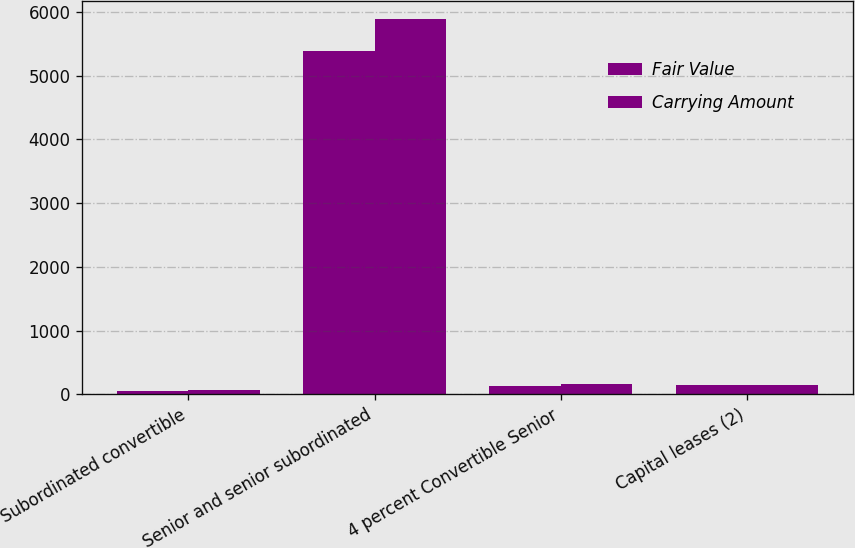<chart> <loc_0><loc_0><loc_500><loc_500><stacked_bar_chart><ecel><fcel>Subordinated convertible<fcel>Senior and senior subordinated<fcel>4 percent Convertible Senior<fcel>Capital leases (2)<nl><fcel>Fair Value<fcel>55<fcel>5387<fcel>137<fcel>148<nl><fcel>Carrying Amount<fcel>63<fcel>5881<fcel>155<fcel>145<nl></chart> 